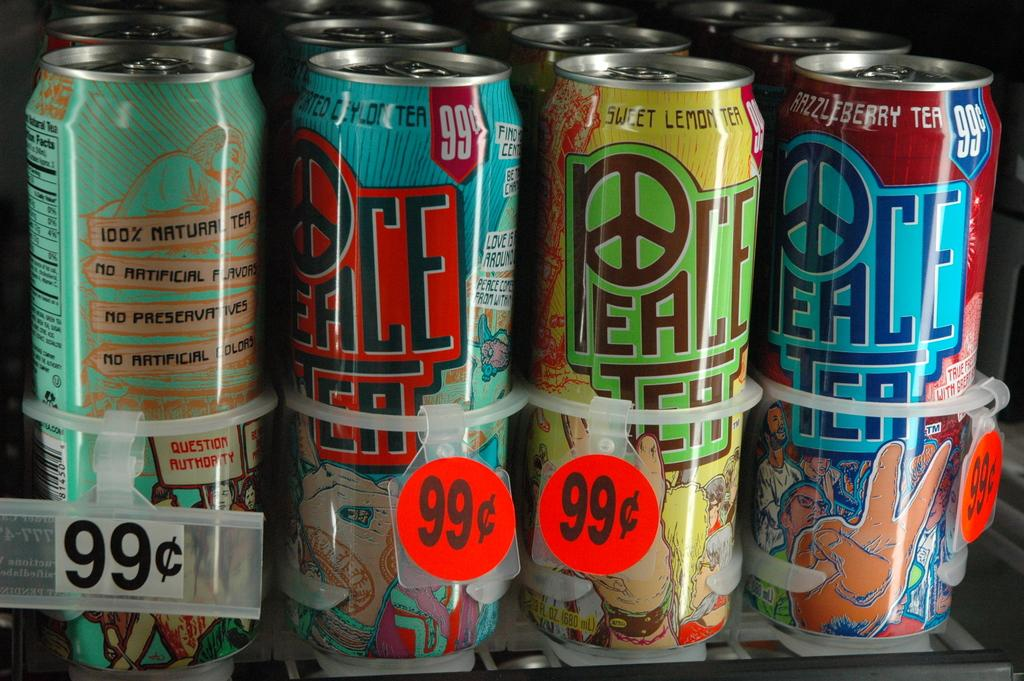<image>
Give a short and clear explanation of the subsequent image. Different color Peace Tea cans that are 99 cents at a store. 